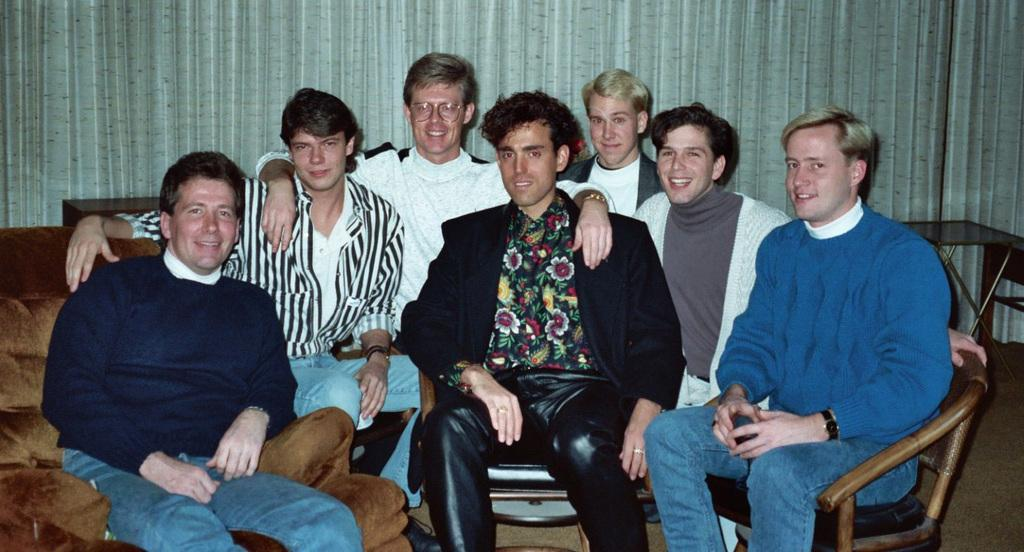How many people are in the image? There are 7 men in the image. What are the men doing in the image? All the men are sitting. What expressions do the men have in the image? All the men are smiling. What can be seen in the background of the image? There is a curtain in the background of the image. What type of brush is being used by the man in the image? There is no brush present in the image; all the men are sitting and smiling. What kind of bun is being held by the man in the image? There is no bun present in the image; all the men are sitting and smiling. 